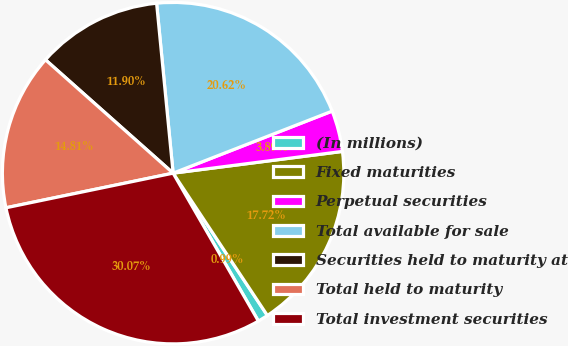Convert chart. <chart><loc_0><loc_0><loc_500><loc_500><pie_chart><fcel>(In millions)<fcel>Fixed maturities<fcel>Perpetual securities<fcel>Total available for sale<fcel>Securities held to maturity at<fcel>Total held to maturity<fcel>Total investment securities<nl><fcel>0.99%<fcel>17.72%<fcel>3.89%<fcel>20.62%<fcel>11.9%<fcel>14.81%<fcel>30.07%<nl></chart> 